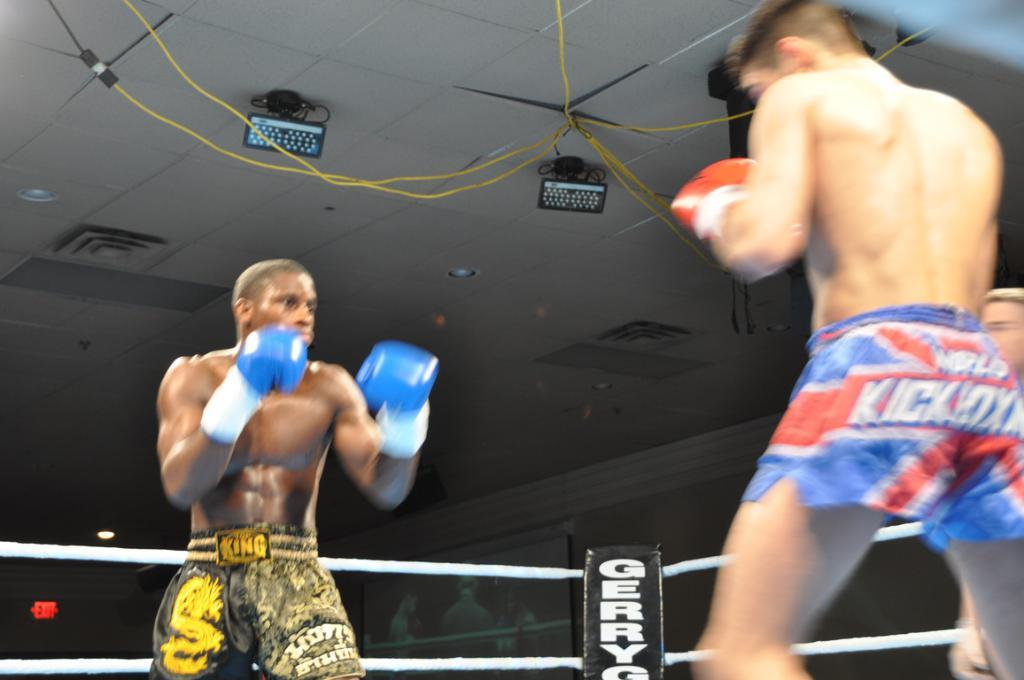<image>
Summarize the visual content of the image. Two boxers are in a ring and one is wearing shorts that say, 'King'. 